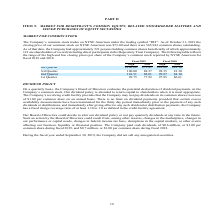According to Amcon Distributing's financial document, What is the closing price of the company's common stock on NYSE American as of October 31, 2019? According to the financial document, $73.00. The relevant text states: "ing price of our common stock on NYSE American was $73.00 and there were 565,942 common shares outstanding. As of that date, the Company had approximately 521..." Also, What are the respective high and low closing prices per share of the Company’s common stock reported by NYSE American for the 1st Quarter of fiscal 2019? The document shows two values: 99.75 and 77.92. From the document: "uarter 101.51 88.01 99.87 84.10 1st Quarter 99.75 77.92 97.85 86.61 2nd Quarter 101.51 88.01 99.87 84.10 1st Quarter 99.75 77.92 97.85 86.61..." Also, What are the respective high and low closing prices per share of the Company’s common stock reported by NYSE American for the 2nd Quarter of fiscal 2019? The document shows two values: 101.51 and 88.01. From the document: "2nd Quarter 101.51 88.01 99.87 84.10 1st Quarter 99.75 77.92 97.85 86.61 2nd Quarter 101.51 88.01 99.87 84.10 1st Quarter 99.75 77.92 97.85 86.61..." Also, can you calculate: What is the average high closing prices per share of the Company’s common stock reported by NYSE American for fiscal 2019? To answer this question, I need to perform calculations using the financial data. The calculation is: (100.00 + 100.00 + 101.51 + 99.75)/4 , which equals 100.31. This is based on the information: "2nd Quarter 101.51 88.01 99.87 84.10 1st Quarter 99.75 77.92 97.85 86.61 4th Quarter $100.00 $73.41 $ 89.00 $ 81.10 2nd Quarter 101.51 88.01 99.87 84.10 1st Quarter 99.75 77.92 97.85 86.61..." The key data points involved are: 100.00, 101.51, 99.75. Also, can you calculate: What is the average high closing prices per share of the Company’s common stock reported by NYSE American for fiscal 2018? To answer this question, I need to perform calculations using the financial data. The calculation is: (89.00 + 98.35 + 99.87 + 97.85)/4 , which equals 96.27. This is based on the information: "101.51 88.01 99.87 84.10 1st Quarter 99.75 77.92 97.85 86.61 4th Quarter $100.00 $73.41 $ 89.00 $ 81.10 2nd Quarter 101.51 88.01 99.87 84.10 1st Quarter 99.75 77.92 97.85 86.61 3rd Quarter 100.00 88.2..." The key data points involved are: 89.00, 97.85, 98.35. Also, can you calculate: What is the percentage change in the high closing prices per share of the Company’s common stock reported by NYSE American between Quarter 4 of fiscal 2018 and 2019? To answer this question, I need to perform calculations using the financial data. The calculation is: (100-89)/89 , which equals 12.36 (percentage). This is based on the information: "4th Quarter $100.00 $73.41 $ 89.00 $ 81.10 4th Quarter $100.00 $73.41 $ 89.00 $ 81.10..." The key data points involved are: 100, 89. 